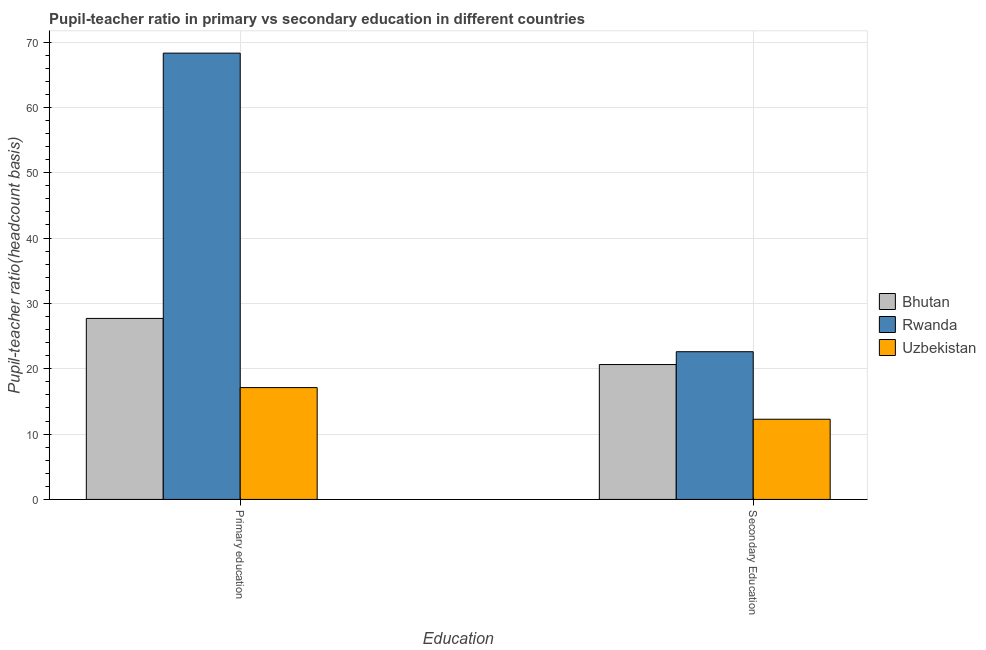Are the number of bars on each tick of the X-axis equal?
Provide a short and direct response. Yes. How many bars are there on the 1st tick from the left?
Ensure brevity in your answer.  3. How many bars are there on the 1st tick from the right?
Provide a short and direct response. 3. What is the label of the 1st group of bars from the left?
Make the answer very short. Primary education. What is the pupil-teacher ratio in primary education in Bhutan?
Provide a short and direct response. 27.7. Across all countries, what is the maximum pupil teacher ratio on secondary education?
Your answer should be compact. 22.61. Across all countries, what is the minimum pupil teacher ratio on secondary education?
Provide a short and direct response. 12.27. In which country was the pupil-teacher ratio in primary education maximum?
Your response must be concise. Rwanda. In which country was the pupil-teacher ratio in primary education minimum?
Keep it short and to the point. Uzbekistan. What is the total pupil-teacher ratio in primary education in the graph?
Your answer should be very brief. 113.12. What is the difference between the pupil-teacher ratio in primary education in Bhutan and that in Rwanda?
Your answer should be very brief. -40.6. What is the difference between the pupil teacher ratio on secondary education in Rwanda and the pupil-teacher ratio in primary education in Uzbekistan?
Your answer should be compact. 5.49. What is the average pupil teacher ratio on secondary education per country?
Your answer should be compact. 18.51. What is the difference between the pupil-teacher ratio in primary education and pupil teacher ratio on secondary education in Bhutan?
Keep it short and to the point. 7.06. What is the ratio of the pupil-teacher ratio in primary education in Rwanda to that in Bhutan?
Offer a terse response. 2.47. Is the pupil-teacher ratio in primary education in Rwanda less than that in Bhutan?
Your answer should be very brief. No. What does the 2nd bar from the left in Primary education represents?
Give a very brief answer. Rwanda. What does the 1st bar from the right in Secondary Education represents?
Provide a short and direct response. Uzbekistan. What is the difference between two consecutive major ticks on the Y-axis?
Offer a very short reply. 10. Are the values on the major ticks of Y-axis written in scientific E-notation?
Your answer should be very brief. No. Does the graph contain grids?
Your answer should be very brief. Yes. Where does the legend appear in the graph?
Your response must be concise. Center right. How many legend labels are there?
Provide a short and direct response. 3. How are the legend labels stacked?
Your answer should be very brief. Vertical. What is the title of the graph?
Offer a very short reply. Pupil-teacher ratio in primary vs secondary education in different countries. Does "Algeria" appear as one of the legend labels in the graph?
Your answer should be very brief. No. What is the label or title of the X-axis?
Your answer should be compact. Education. What is the label or title of the Y-axis?
Offer a terse response. Pupil-teacher ratio(headcount basis). What is the Pupil-teacher ratio(headcount basis) of Bhutan in Primary education?
Offer a very short reply. 27.7. What is the Pupil-teacher ratio(headcount basis) in Rwanda in Primary education?
Offer a terse response. 68.3. What is the Pupil-teacher ratio(headcount basis) of Uzbekistan in Primary education?
Your answer should be very brief. 17.12. What is the Pupil-teacher ratio(headcount basis) of Bhutan in Secondary Education?
Provide a short and direct response. 20.64. What is the Pupil-teacher ratio(headcount basis) of Rwanda in Secondary Education?
Offer a very short reply. 22.61. What is the Pupil-teacher ratio(headcount basis) in Uzbekistan in Secondary Education?
Give a very brief answer. 12.27. Across all Education, what is the maximum Pupil-teacher ratio(headcount basis) of Bhutan?
Offer a very short reply. 27.7. Across all Education, what is the maximum Pupil-teacher ratio(headcount basis) of Rwanda?
Your answer should be compact. 68.3. Across all Education, what is the maximum Pupil-teacher ratio(headcount basis) of Uzbekistan?
Your answer should be very brief. 17.12. Across all Education, what is the minimum Pupil-teacher ratio(headcount basis) in Bhutan?
Your response must be concise. 20.64. Across all Education, what is the minimum Pupil-teacher ratio(headcount basis) in Rwanda?
Provide a short and direct response. 22.61. Across all Education, what is the minimum Pupil-teacher ratio(headcount basis) in Uzbekistan?
Provide a short and direct response. 12.27. What is the total Pupil-teacher ratio(headcount basis) in Bhutan in the graph?
Your response must be concise. 48.35. What is the total Pupil-teacher ratio(headcount basis) in Rwanda in the graph?
Give a very brief answer. 90.9. What is the total Pupil-teacher ratio(headcount basis) in Uzbekistan in the graph?
Ensure brevity in your answer.  29.39. What is the difference between the Pupil-teacher ratio(headcount basis) in Bhutan in Primary education and that in Secondary Education?
Make the answer very short. 7.06. What is the difference between the Pupil-teacher ratio(headcount basis) in Rwanda in Primary education and that in Secondary Education?
Offer a very short reply. 45.69. What is the difference between the Pupil-teacher ratio(headcount basis) of Uzbekistan in Primary education and that in Secondary Education?
Ensure brevity in your answer.  4.84. What is the difference between the Pupil-teacher ratio(headcount basis) of Bhutan in Primary education and the Pupil-teacher ratio(headcount basis) of Rwanda in Secondary Education?
Your response must be concise. 5.1. What is the difference between the Pupil-teacher ratio(headcount basis) in Bhutan in Primary education and the Pupil-teacher ratio(headcount basis) in Uzbekistan in Secondary Education?
Give a very brief answer. 15.43. What is the difference between the Pupil-teacher ratio(headcount basis) in Rwanda in Primary education and the Pupil-teacher ratio(headcount basis) in Uzbekistan in Secondary Education?
Give a very brief answer. 56.03. What is the average Pupil-teacher ratio(headcount basis) in Bhutan per Education?
Give a very brief answer. 24.17. What is the average Pupil-teacher ratio(headcount basis) of Rwanda per Education?
Provide a short and direct response. 45.45. What is the average Pupil-teacher ratio(headcount basis) in Uzbekistan per Education?
Make the answer very short. 14.69. What is the difference between the Pupil-teacher ratio(headcount basis) of Bhutan and Pupil-teacher ratio(headcount basis) of Rwanda in Primary education?
Your response must be concise. -40.6. What is the difference between the Pupil-teacher ratio(headcount basis) in Bhutan and Pupil-teacher ratio(headcount basis) in Uzbekistan in Primary education?
Give a very brief answer. 10.59. What is the difference between the Pupil-teacher ratio(headcount basis) of Rwanda and Pupil-teacher ratio(headcount basis) of Uzbekistan in Primary education?
Your answer should be very brief. 51.18. What is the difference between the Pupil-teacher ratio(headcount basis) of Bhutan and Pupil-teacher ratio(headcount basis) of Rwanda in Secondary Education?
Provide a succinct answer. -1.96. What is the difference between the Pupil-teacher ratio(headcount basis) of Bhutan and Pupil-teacher ratio(headcount basis) of Uzbekistan in Secondary Education?
Your response must be concise. 8.37. What is the difference between the Pupil-teacher ratio(headcount basis) in Rwanda and Pupil-teacher ratio(headcount basis) in Uzbekistan in Secondary Education?
Ensure brevity in your answer.  10.33. What is the ratio of the Pupil-teacher ratio(headcount basis) in Bhutan in Primary education to that in Secondary Education?
Offer a very short reply. 1.34. What is the ratio of the Pupil-teacher ratio(headcount basis) of Rwanda in Primary education to that in Secondary Education?
Your answer should be very brief. 3.02. What is the ratio of the Pupil-teacher ratio(headcount basis) in Uzbekistan in Primary education to that in Secondary Education?
Provide a short and direct response. 1.39. What is the difference between the highest and the second highest Pupil-teacher ratio(headcount basis) of Bhutan?
Your answer should be very brief. 7.06. What is the difference between the highest and the second highest Pupil-teacher ratio(headcount basis) in Rwanda?
Make the answer very short. 45.69. What is the difference between the highest and the second highest Pupil-teacher ratio(headcount basis) of Uzbekistan?
Your answer should be very brief. 4.84. What is the difference between the highest and the lowest Pupil-teacher ratio(headcount basis) in Bhutan?
Offer a very short reply. 7.06. What is the difference between the highest and the lowest Pupil-teacher ratio(headcount basis) of Rwanda?
Give a very brief answer. 45.69. What is the difference between the highest and the lowest Pupil-teacher ratio(headcount basis) in Uzbekistan?
Make the answer very short. 4.84. 